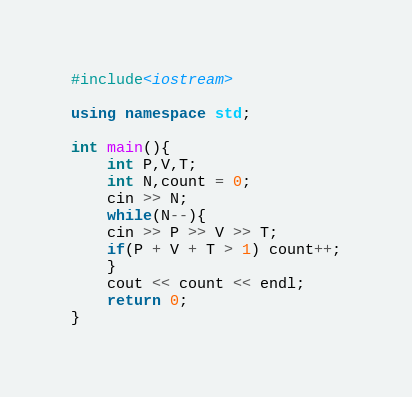Convert code to text. <code><loc_0><loc_0><loc_500><loc_500><_C++_>#include<iostream>

using namespace std;

int main(){
	int P,V,T;
	int N,count = 0;
	cin >> N;
	while(N--){
	cin >> P >> V >> T;
	if(P + V + T > 1) count++;
	}
	cout << count << endl;
	return 0;
}
</code> 